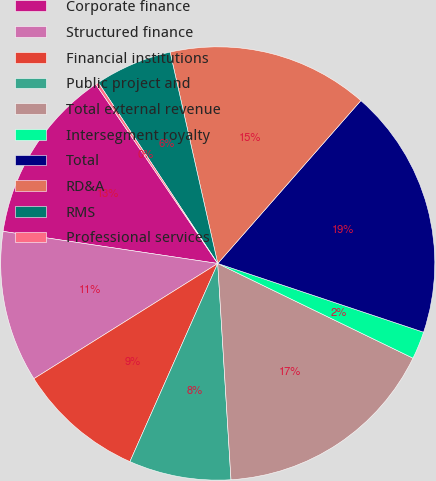Convert chart to OTSL. <chart><loc_0><loc_0><loc_500><loc_500><pie_chart><fcel>Corporate finance<fcel>Structured finance<fcel>Financial institutions<fcel>Public project and<fcel>Total external revenue<fcel>Intersegment royalty<fcel>Total<fcel>RD&A<fcel>RMS<fcel>Professional services<nl><fcel>13.14%<fcel>11.29%<fcel>9.45%<fcel>7.6%<fcel>16.83%<fcel>2.06%<fcel>18.68%<fcel>14.98%<fcel>5.75%<fcel>0.22%<nl></chart> 